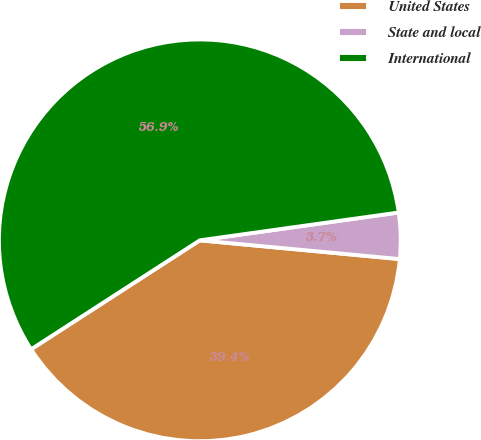Convert chart. <chart><loc_0><loc_0><loc_500><loc_500><pie_chart><fcel>United States<fcel>State and local<fcel>International<nl><fcel>39.38%<fcel>3.7%<fcel>56.91%<nl></chart> 